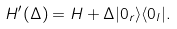<formula> <loc_0><loc_0><loc_500><loc_500>H ^ { \prime } ( \Delta ) = H + \Delta | 0 _ { r } \rangle \langle 0 _ { l } | .</formula> 